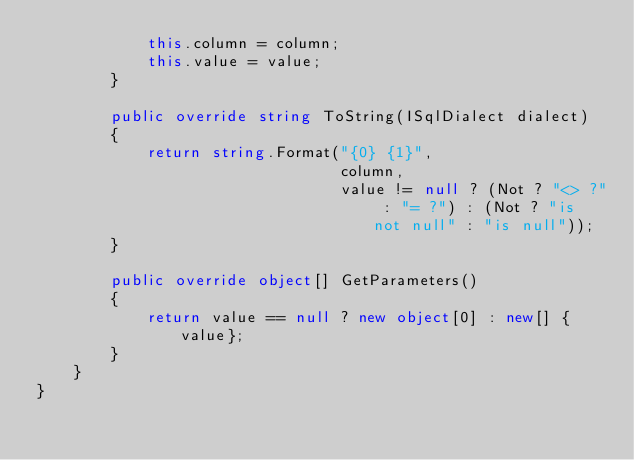<code> <loc_0><loc_0><loc_500><loc_500><_C#_>            this.column = column;
            this.value = value;
        }

        public override string ToString(ISqlDialect dialect)
        {
            return string.Format("{0} {1}",
                                 column,
                                 value != null ? (Not ? "<> ?" : "= ?") : (Not ? "is not null" : "is null"));
        }

        public override object[] GetParameters()
        {
            return value == null ? new object[0] : new[] {value};
        }
    }
}</code> 